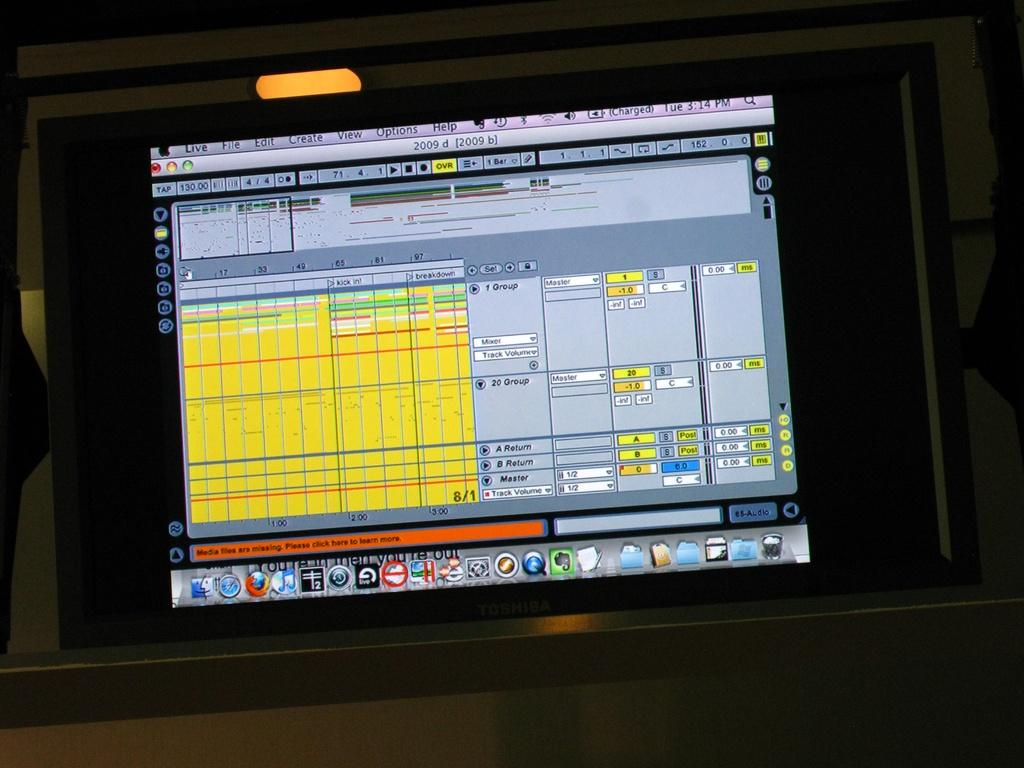Provide a one-sentence caption for the provided image. Toshiba computer monitor with a screen that says "Live" on the top left. 